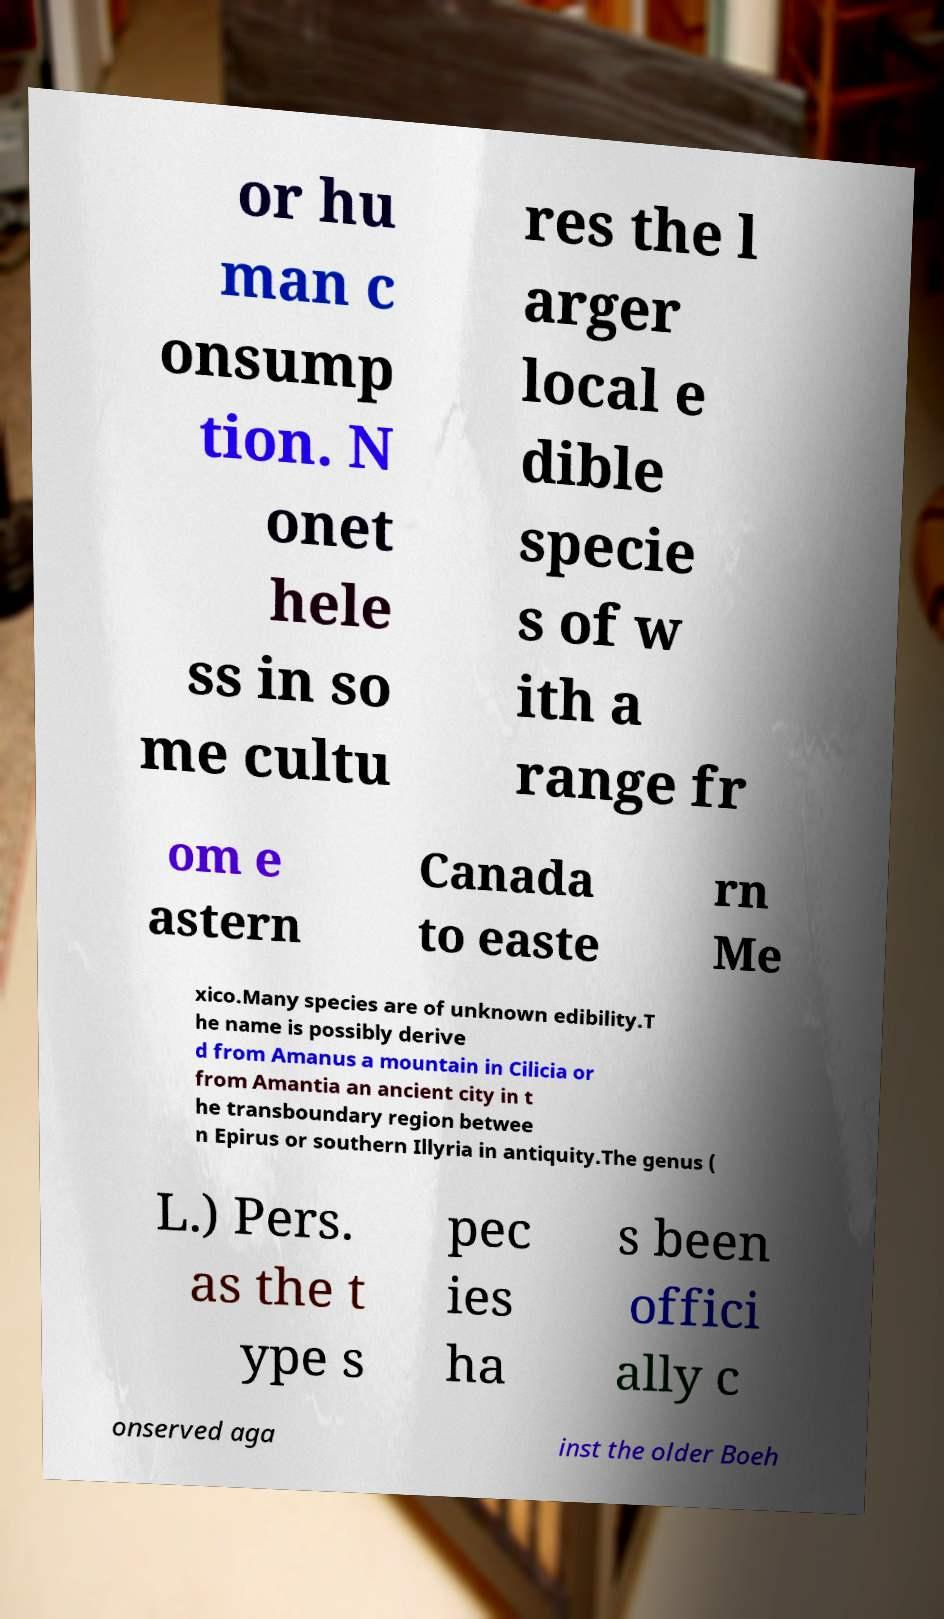For documentation purposes, I need the text within this image transcribed. Could you provide that? or hu man c onsump tion. N onet hele ss in so me cultu res the l arger local e dible specie s of w ith a range fr om e astern Canada to easte rn Me xico.Many species are of unknown edibility.T he name is possibly derive d from Amanus a mountain in Cilicia or from Amantia an ancient city in t he transboundary region betwee n Epirus or southern Illyria in antiquity.The genus ( L.) Pers. as the t ype s pec ies ha s been offici ally c onserved aga inst the older Boeh 